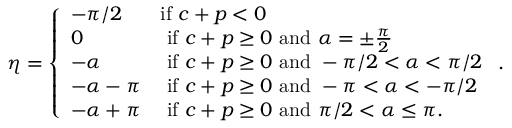<formula> <loc_0><loc_0><loc_500><loc_500>\eta = \left \{ \begin{array} { l l } { - \pi / 2 } & { i f c + p < 0 } \\ { 0 } & { i f c + p \geq 0 a n d \alpha = \pm \frac { \pi } { 2 } } \\ { - \alpha } & { i f c + p \geq 0 a n d - \pi / 2 < \alpha < \pi / 2 } \\ { - \alpha - \pi } & { i f c + p \geq 0 a n d - \pi < \alpha < - \pi / 2 } \\ { - \alpha + \pi } & { i f c + p \geq 0 a n d \pi / 2 < \alpha \leq \pi . } \end{array} .</formula> 